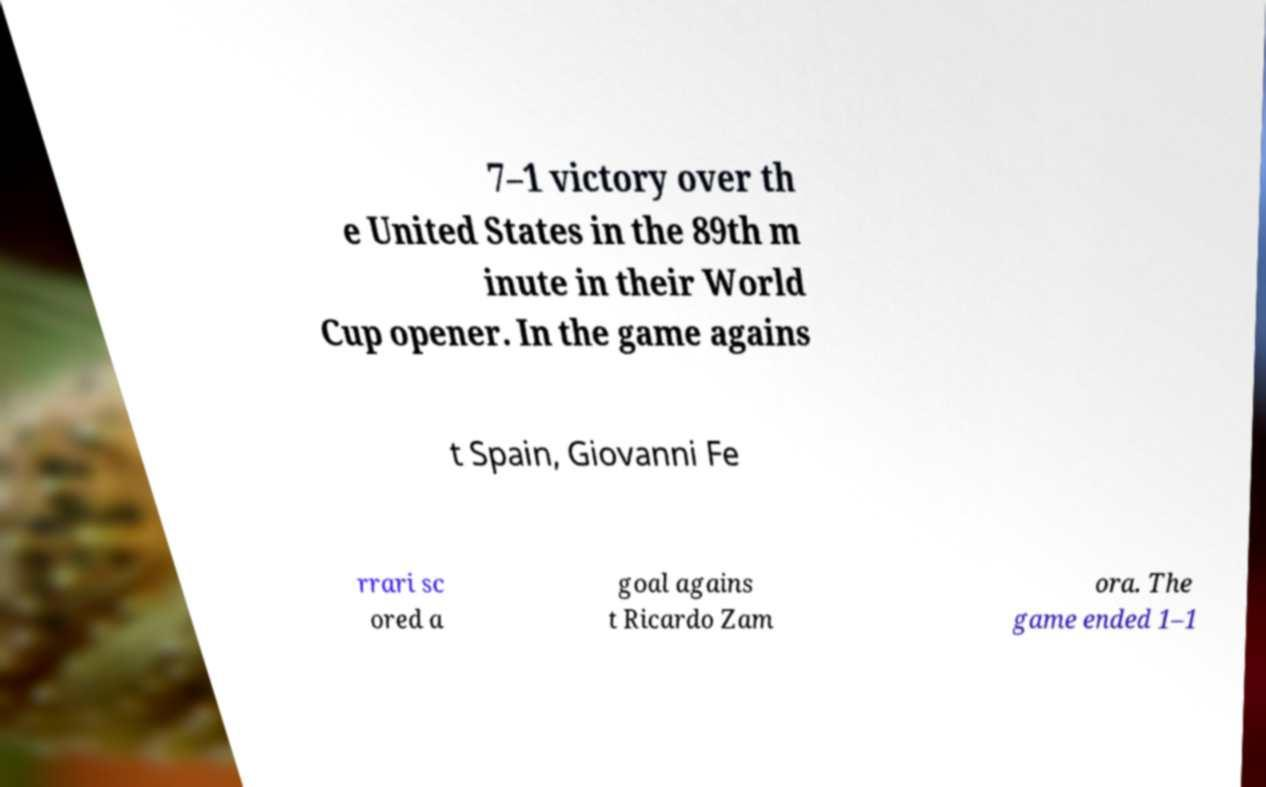Please read and relay the text visible in this image. What does it say? 7–1 victory over th e United States in the 89th m inute in their World Cup opener. In the game agains t Spain, Giovanni Fe rrari sc ored a goal agains t Ricardo Zam ora. The game ended 1–1 